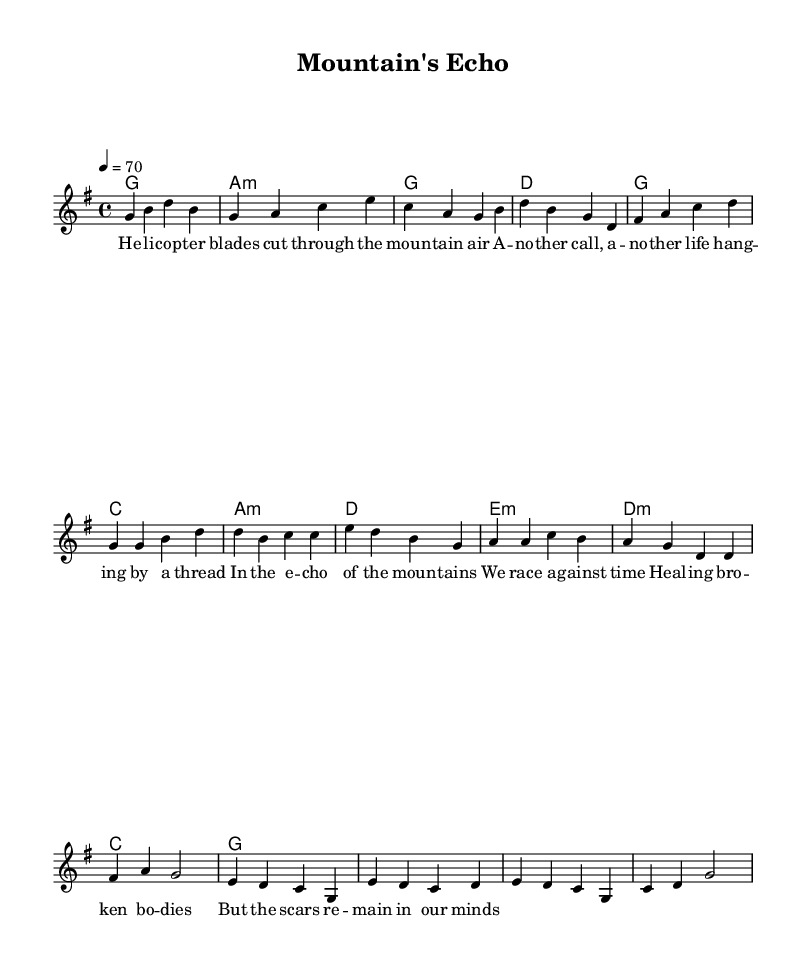What is the key signature of this music? The key signature indicated at the beginning shows one sharp, meaning it is in G major.
Answer: G major What is the time signature of this music? The time signature appears as a "4/4" at the beginning of the score, indicating common time with four beats per measure.
Answer: 4/4 What is the tempo marking for the piece? The tempo marking is shown as "4 = 70," meaning there should be 70 quarter note beats per minute.
Answer: 70 How many measures are in the verse section? By counting the number of measures in the melody section labeled "Verse," there are four measures in that part.
Answer: 4 Which chord follows the G major chord in the verse? The chord progression shows that after the G major, the next chord is A minor. This is evident in the harmonies section under the verse label.
Answer: A minor What is the primary theme of the lyrics? The lyrics reflect on the emotional challenges faced by emergency medical responders, specifically relating to their experiences in mountainous environments.
Answer: Emotional challenges What type of musical form is primarily used in this piece? The structure of having distinct verses and a repeating chorus suggests that it follows a verse-chorus form typical of country rock music.
Answer: Verse-Chorus form 